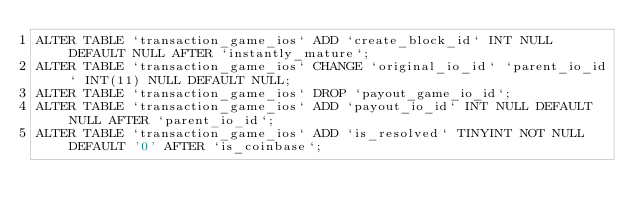<code> <loc_0><loc_0><loc_500><loc_500><_SQL_>ALTER TABLE `transaction_game_ios` ADD `create_block_id` INT NULL DEFAULT NULL AFTER `instantly_mature`;
ALTER TABLE `transaction_game_ios` CHANGE `original_io_id` `parent_io_id` INT(11) NULL DEFAULT NULL;
ALTER TABLE `transaction_game_ios` DROP `payout_game_io_id`;
ALTER TABLE `transaction_game_ios` ADD `payout_io_id` INT NULL DEFAULT NULL AFTER `parent_io_id`;
ALTER TABLE `transaction_game_ios` ADD `is_resolved` TINYINT NOT NULL DEFAULT '0' AFTER `is_coinbase`;</code> 